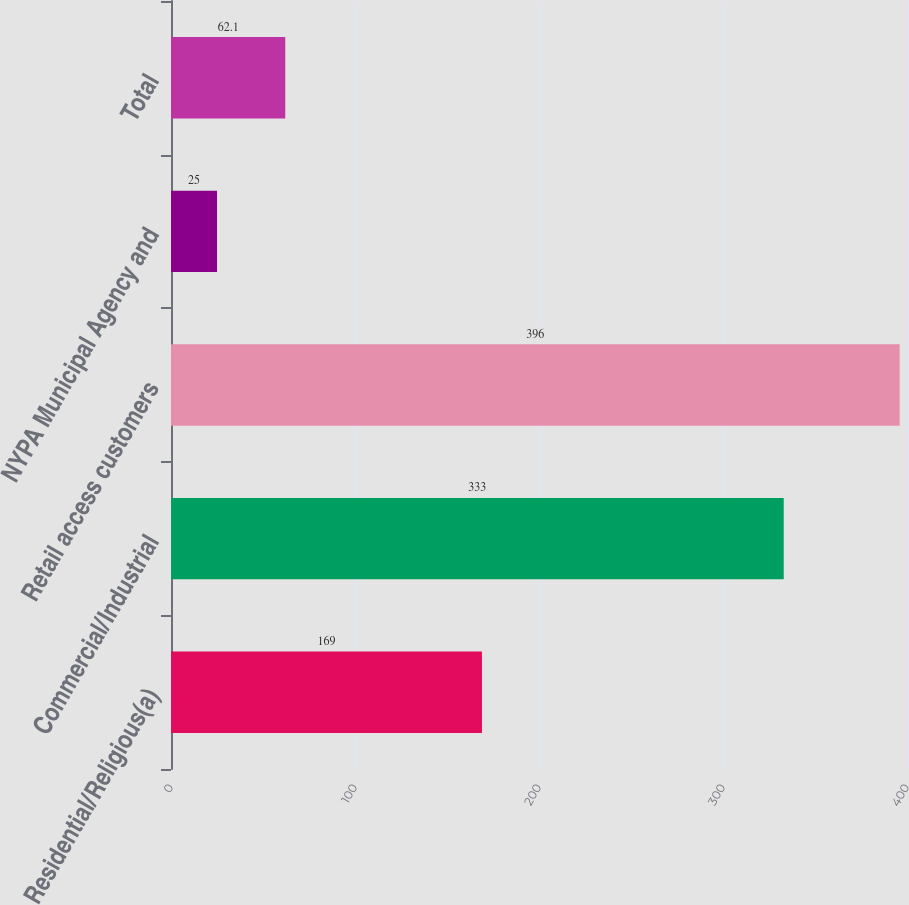Convert chart. <chart><loc_0><loc_0><loc_500><loc_500><bar_chart><fcel>Residential/Religious(a)<fcel>Commercial/Industrial<fcel>Retail access customers<fcel>NYPA Municipal Agency and<fcel>Total<nl><fcel>169<fcel>333<fcel>396<fcel>25<fcel>62.1<nl></chart> 